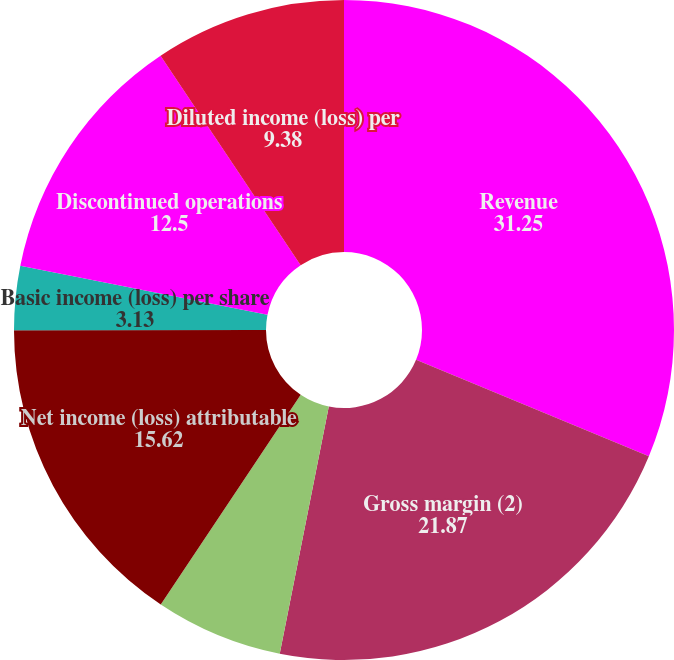Convert chart. <chart><loc_0><loc_0><loc_500><loc_500><pie_chart><fcel>Revenue<fcel>Gross margin (2)<fcel>Income from continuing<fcel>Net income (loss) attributable<fcel>Basic income (loss) per share<fcel>Discontinued operations<fcel>Diluted income (loss) per<nl><fcel>31.25%<fcel>21.87%<fcel>6.25%<fcel>15.62%<fcel>3.13%<fcel>12.5%<fcel>9.38%<nl></chart> 